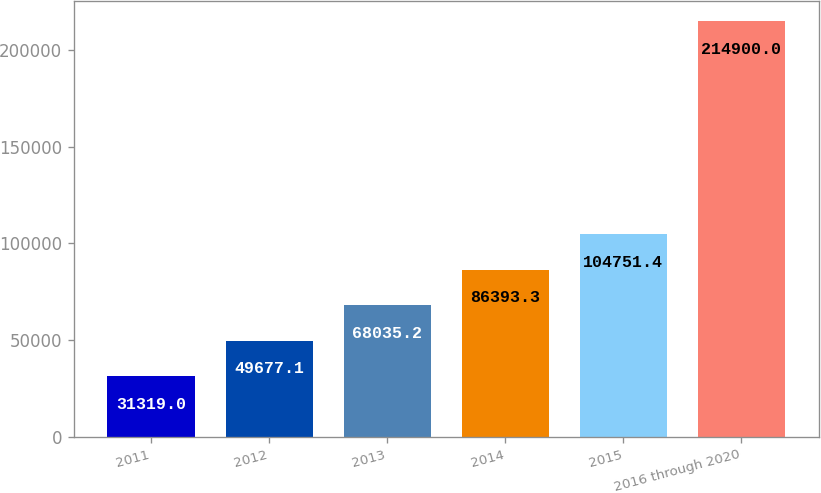Convert chart to OTSL. <chart><loc_0><loc_0><loc_500><loc_500><bar_chart><fcel>2011<fcel>2012<fcel>2013<fcel>2014<fcel>2015<fcel>2016 through 2020<nl><fcel>31319<fcel>49677.1<fcel>68035.2<fcel>86393.3<fcel>104751<fcel>214900<nl></chart> 